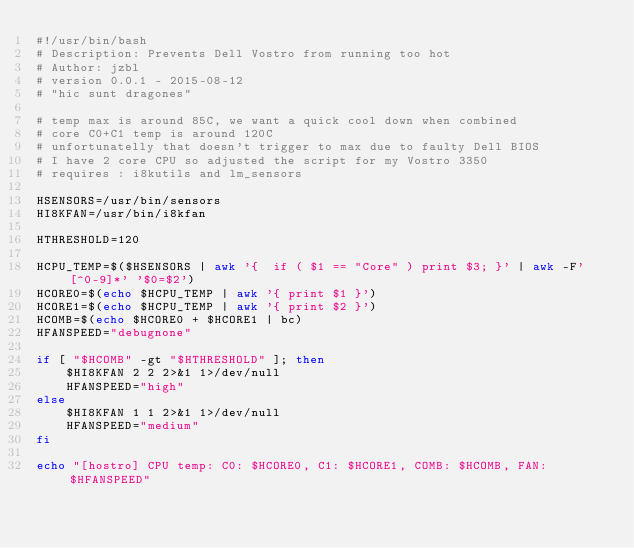<code> <loc_0><loc_0><loc_500><loc_500><_Bash_>#!/usr/bin/bash
# Description: Prevents Dell Vostro from running too hot
# Author: jzbl
# version 0.0.1 - 2015-08-12
# "hic sunt dragones"

# temp max is around 85C, we want a quick cool down when combined
# core C0+C1 temp is around 120C
# unfortunatelly that doesn't trigger to max due to faulty Dell BIOS
# I have 2 core CPU so adjusted the script for my Vostro 3350 
# requires : i8kutils and lm_sensors

HSENSORS=/usr/bin/sensors
HI8KFAN=/usr/bin/i8kfan

HTHRESHOLD=120

HCPU_TEMP=$($HSENSORS | awk '{  if ( $1 == "Core" ) print $3; }' | awk -F'[^0-9]*' '$0=$2')
HCORE0=$(echo $HCPU_TEMP | awk '{ print $1 }')
HCORE1=$(echo $HCPU_TEMP | awk '{ print $2 }')
HCOMB=$(echo $HCORE0 + $HCORE1 | bc)
HFANSPEED="debugnone"

if [ "$HCOMB" -gt "$HTHRESHOLD" ]; then
	$HI8KFAN 2 2 2>&1 1>/dev/null
	HFANSPEED="high"
else
	$HI8KFAN 1 1 2>&1 1>/dev/null
	HFANSPEED="medium"
fi

echo "[hostro] CPU temp: C0: $HCORE0, C1: $HCORE1, COMB: $HCOMB, FAN: $HFANSPEED"
</code> 